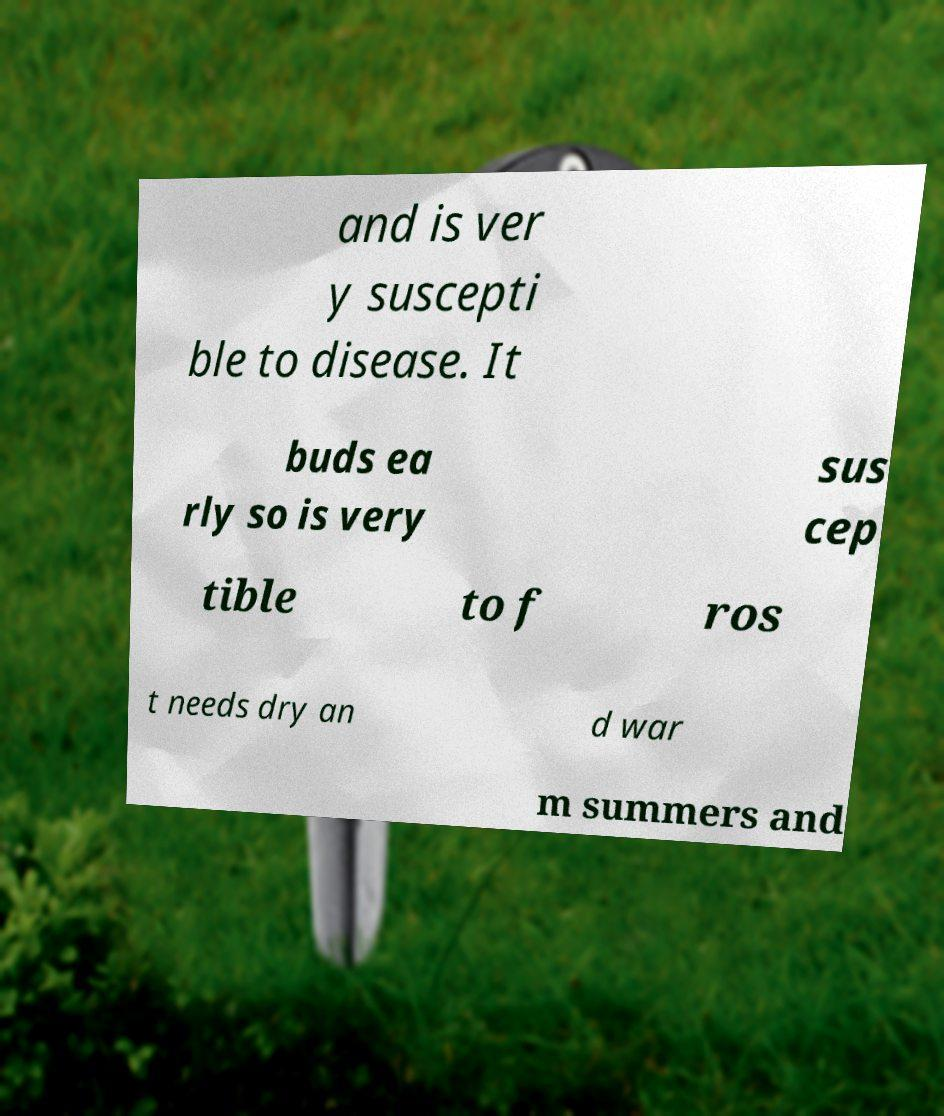Could you extract and type out the text from this image? and is ver y suscepti ble to disease. It buds ea rly so is very sus cep tible to f ros t needs dry an d war m summers and 